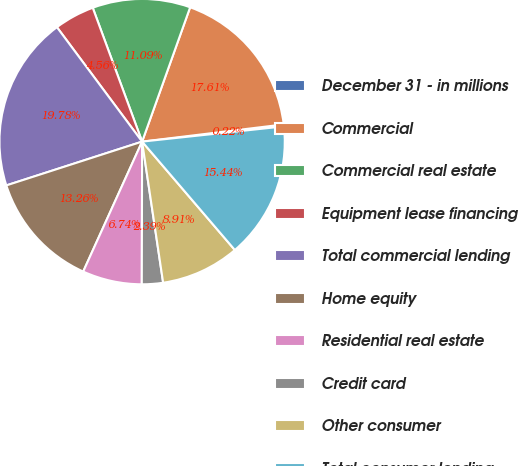Convert chart to OTSL. <chart><loc_0><loc_0><loc_500><loc_500><pie_chart><fcel>December 31 - in millions<fcel>Commercial<fcel>Commercial real estate<fcel>Equipment lease financing<fcel>Total commercial lending<fcel>Home equity<fcel>Residential real estate<fcel>Credit card<fcel>Other consumer<fcel>Total consumer lending<nl><fcel>0.22%<fcel>17.61%<fcel>11.09%<fcel>4.56%<fcel>19.78%<fcel>13.26%<fcel>6.74%<fcel>2.39%<fcel>8.91%<fcel>15.44%<nl></chart> 